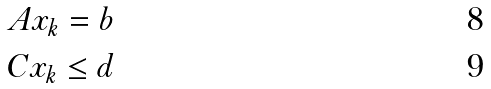Convert formula to latex. <formula><loc_0><loc_0><loc_500><loc_500>A x _ { k } = b \\ C x _ { k } \leq d</formula> 